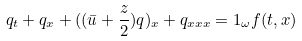Convert formula to latex. <formula><loc_0><loc_0><loc_500><loc_500>q _ { t } + q _ { x } + ( ( \bar { u } + \frac { z } { 2 } ) q ) _ { x } + q _ { x x x } = 1 _ { \omega } f ( t , x )</formula> 